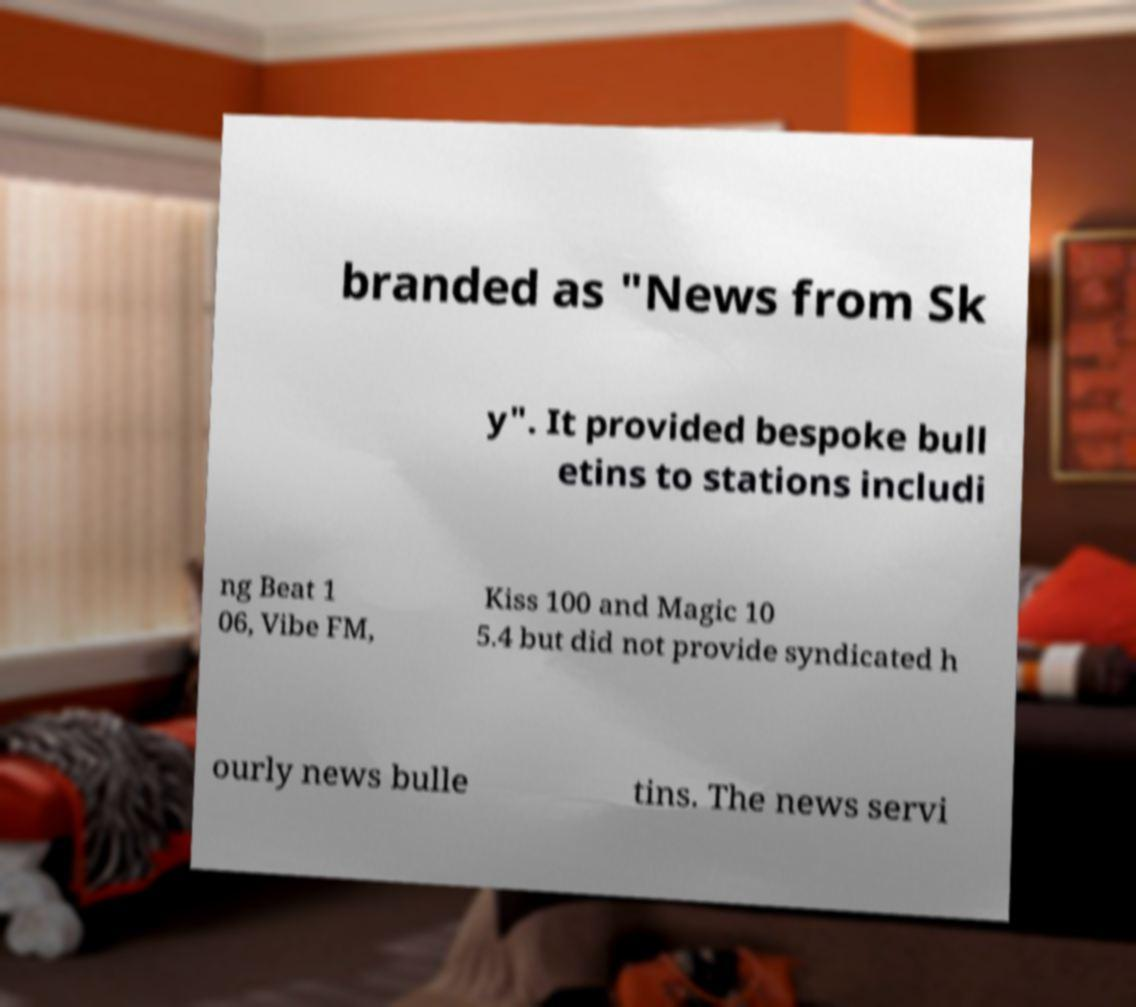I need the written content from this picture converted into text. Can you do that? branded as "News from Sk y". It provided bespoke bull etins to stations includi ng Beat 1 06, Vibe FM, Kiss 100 and Magic 10 5.4 but did not provide syndicated h ourly news bulle tins. The news servi 